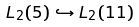Convert formula to latex. <formula><loc_0><loc_0><loc_500><loc_500>L _ { 2 } ( 5 ) \hookrightarrow L _ { 2 } ( 1 1 )</formula> 